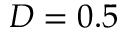<formula> <loc_0><loc_0><loc_500><loc_500>D = 0 . 5</formula> 